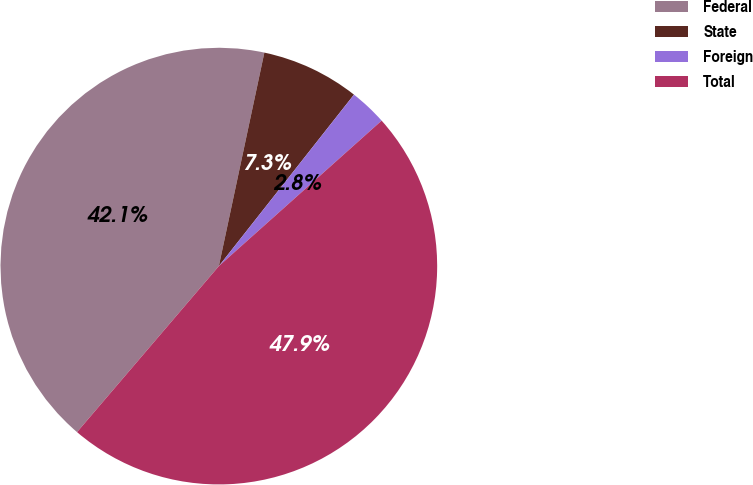Convert chart to OTSL. <chart><loc_0><loc_0><loc_500><loc_500><pie_chart><fcel>Federal<fcel>State<fcel>Foreign<fcel>Total<nl><fcel>42.09%<fcel>7.28%<fcel>2.77%<fcel>47.86%<nl></chart> 